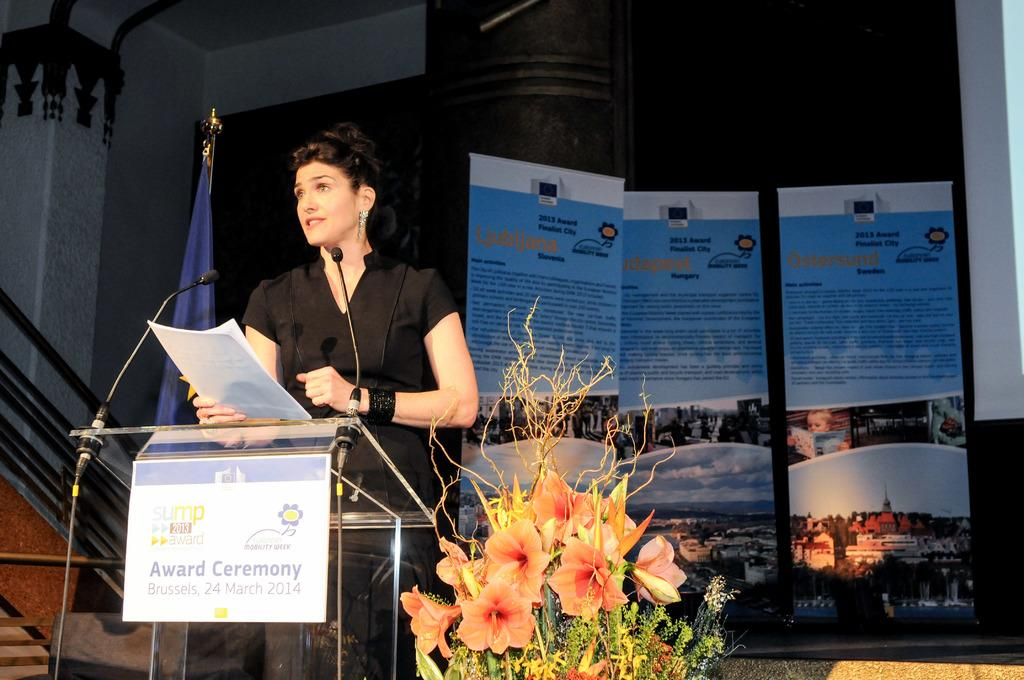Who is the main subject in the image? There is a woman in the image. What is the woman doing in the image? The woman is standing in the image. What is the woman holding in the image? The woman is holding white color papers in the image. What other objects can be seen in the image? There are microphones in the image. What can be seen in the background of the image? There are posters in the background of the image. What type of kettle is visible in the image? There is no kettle present in the image. What month is the woman celebrating in the image? The image does not indicate any specific month or celebration. 